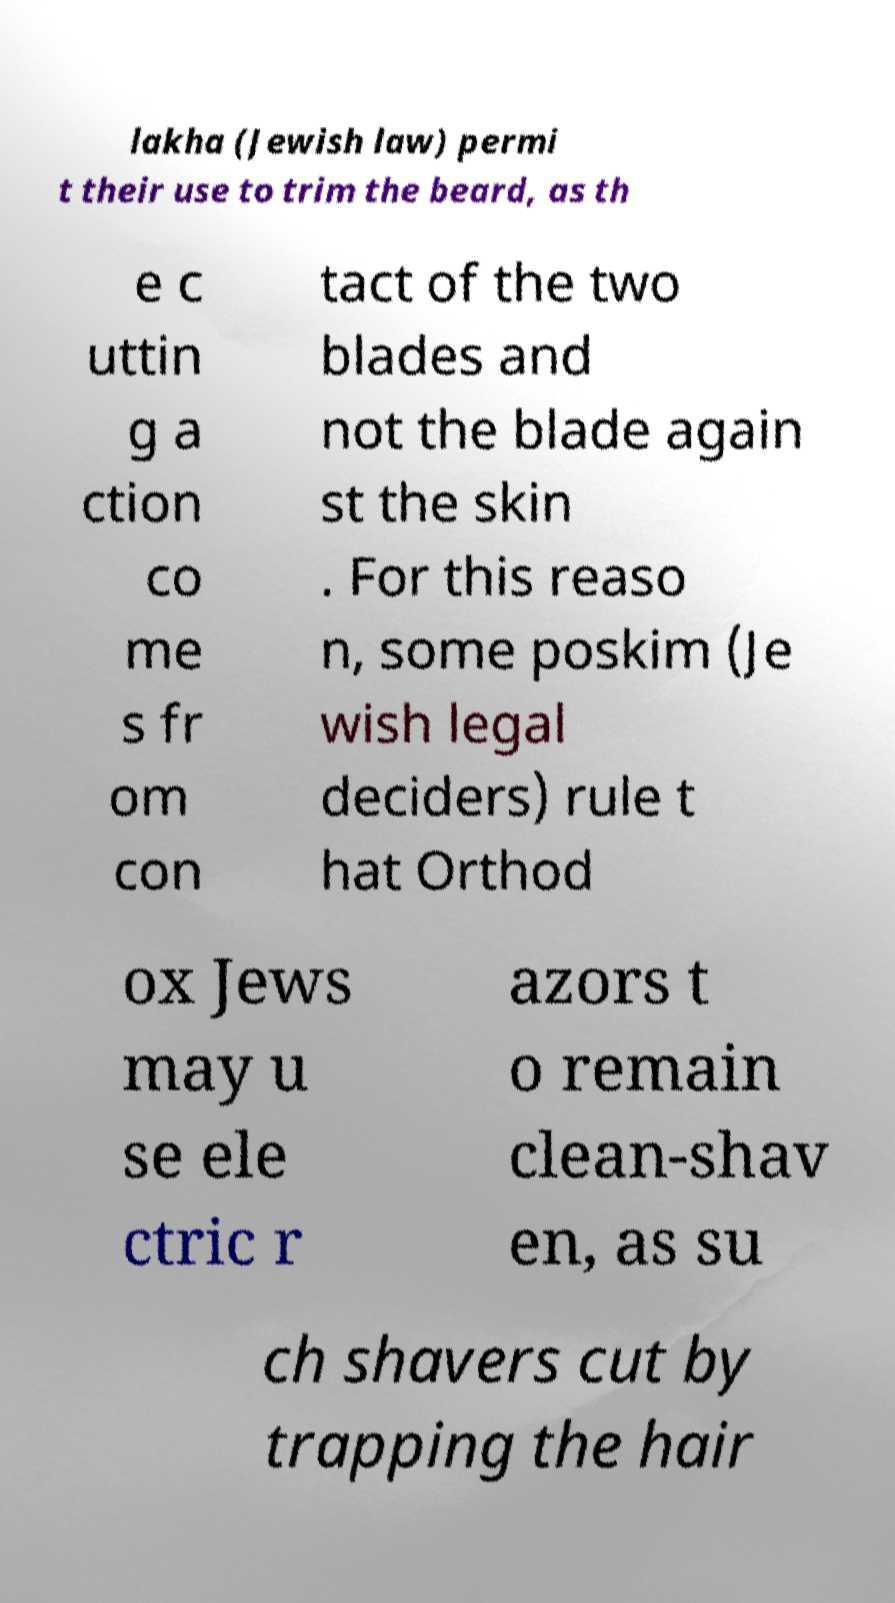Please read and relay the text visible in this image. What does it say? lakha (Jewish law) permi t their use to trim the beard, as th e c uttin g a ction co me s fr om con tact of the two blades and not the blade again st the skin . For this reaso n, some poskim (Je wish legal deciders) rule t hat Orthod ox Jews may u se ele ctric r azors t o remain clean-shav en, as su ch shavers cut by trapping the hair 